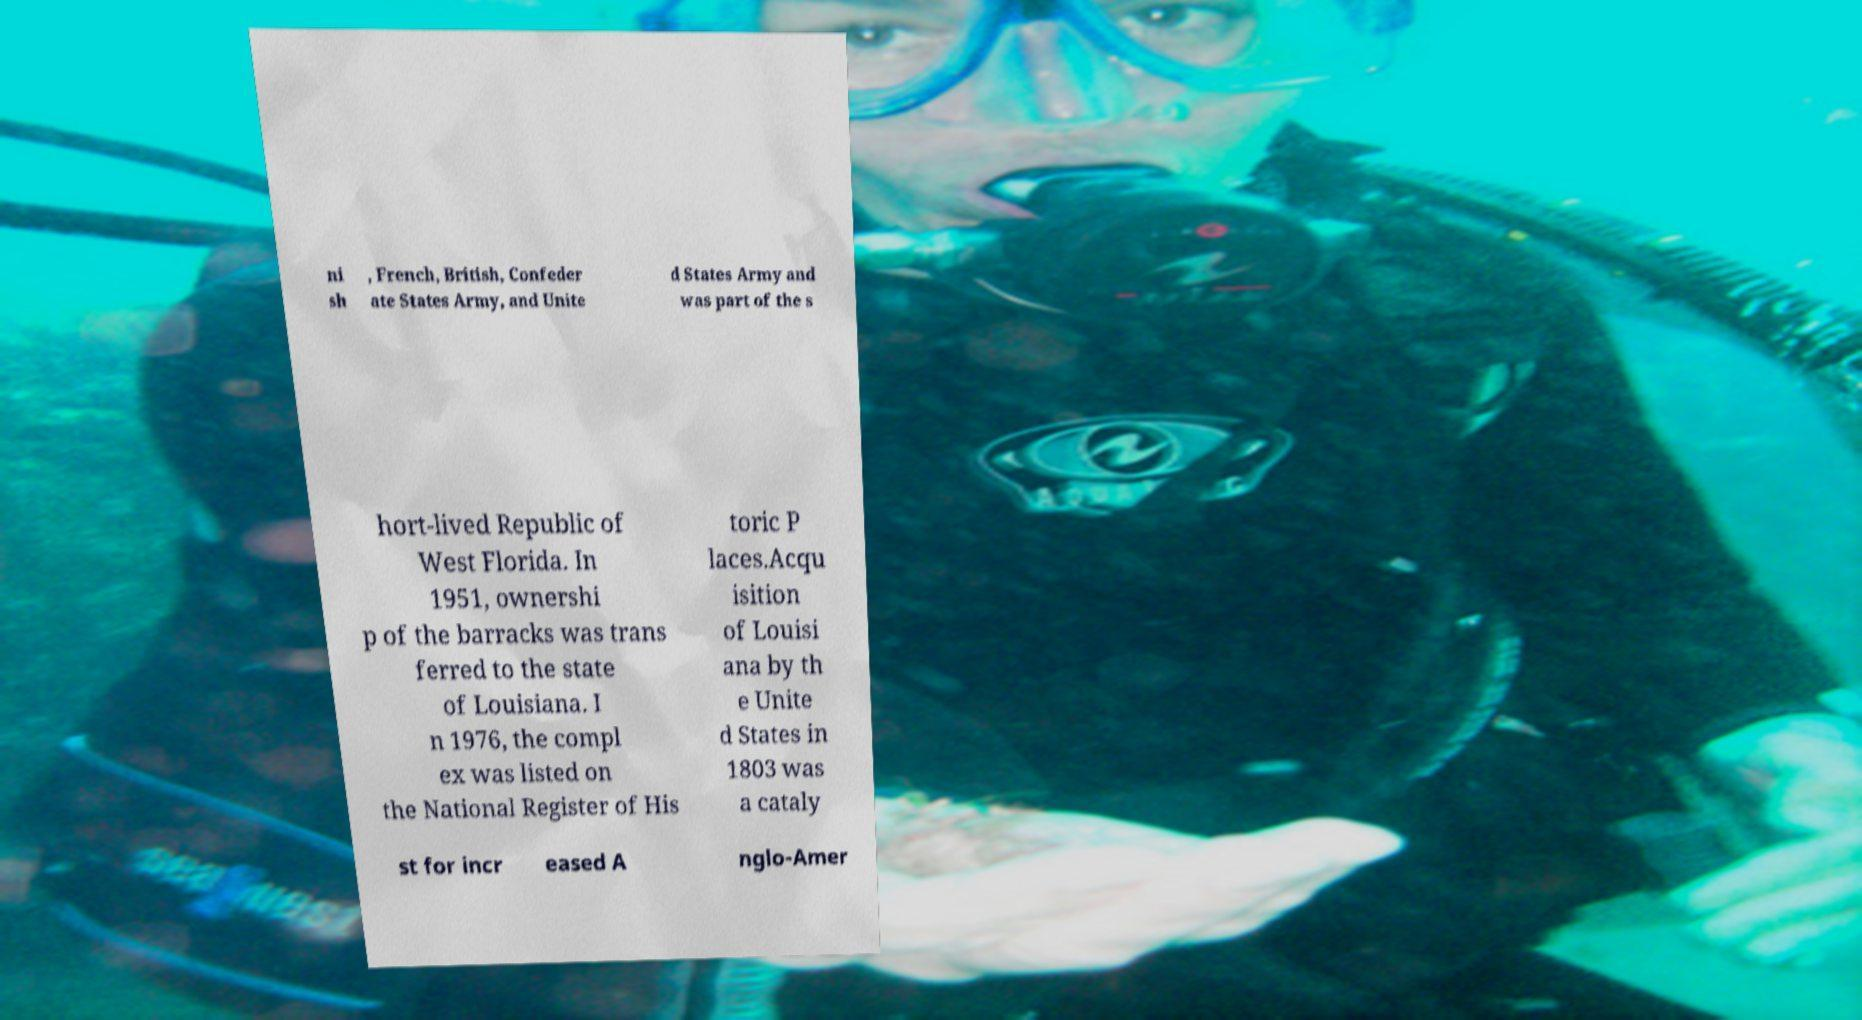Can you read and provide the text displayed in the image?This photo seems to have some interesting text. Can you extract and type it out for me? ni sh , French, British, Confeder ate States Army, and Unite d States Army and was part of the s hort-lived Republic of West Florida. In 1951, ownershi p of the barracks was trans ferred to the state of Louisiana. I n 1976, the compl ex was listed on the National Register of His toric P laces.Acqu isition of Louisi ana by th e Unite d States in 1803 was a cataly st for incr eased A nglo-Amer 